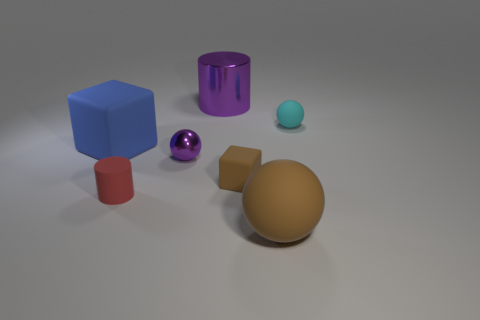Add 3 large metal cylinders. How many objects exist? 10 Subtract all purple spheres. How many spheres are left? 2 Add 4 small brown cylinders. How many small brown cylinders exist? 4 Subtract all red cylinders. How many cylinders are left? 1 Subtract 1 blue blocks. How many objects are left? 6 Subtract all balls. How many objects are left? 4 Subtract 3 spheres. How many spheres are left? 0 Subtract all red cylinders. Subtract all yellow spheres. How many cylinders are left? 1 Subtract all purple blocks. How many red cylinders are left? 1 Subtract all gray metal cubes. Subtract all small purple metal balls. How many objects are left? 6 